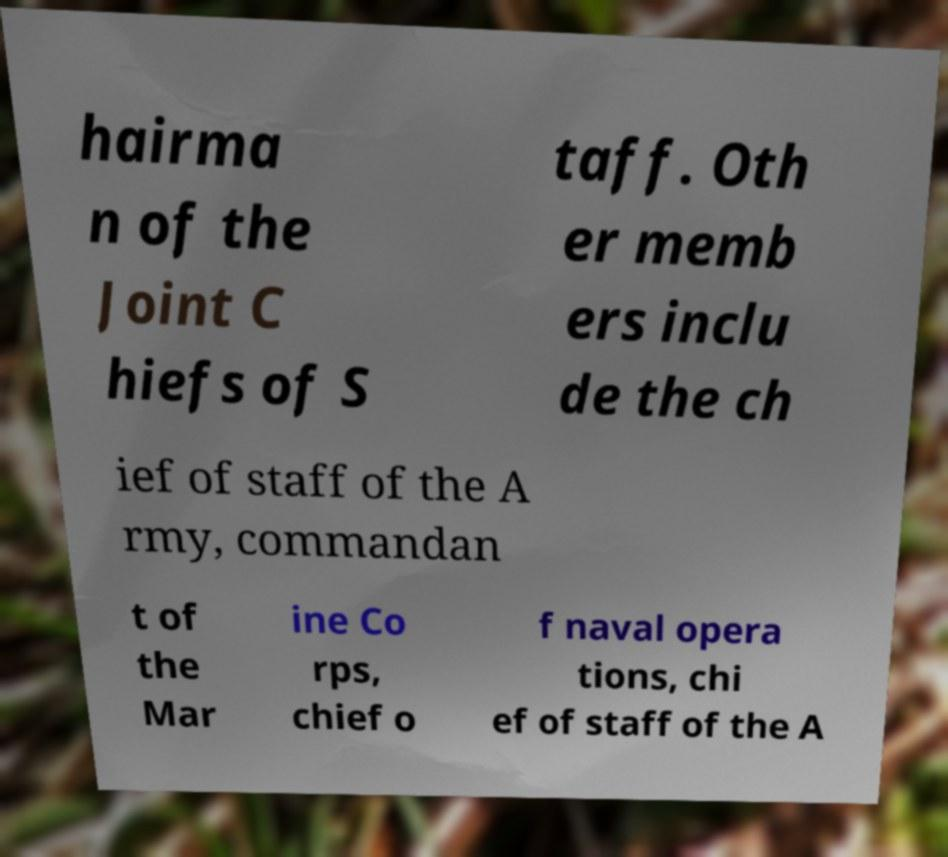Could you extract and type out the text from this image? hairma n of the Joint C hiefs of S taff. Oth er memb ers inclu de the ch ief of staff of the A rmy, commandan t of the Mar ine Co rps, chief o f naval opera tions, chi ef of staff of the A 